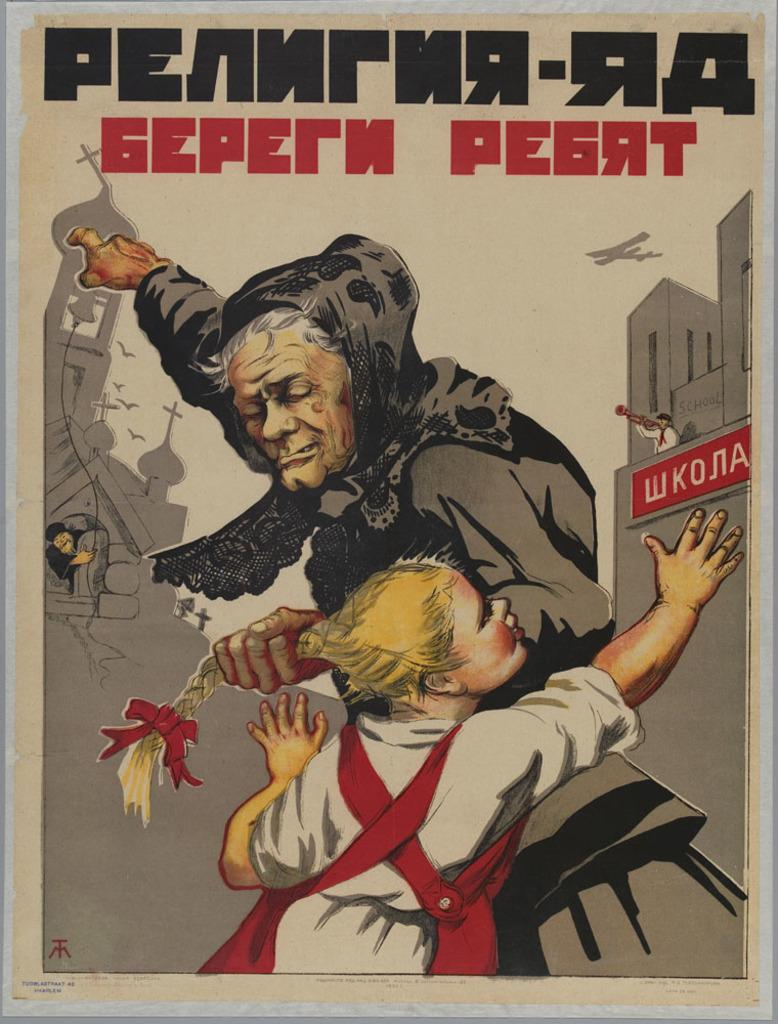What type of artwork is depicted in the image? The image is a painting. Who or what can be seen in the painting? There is a woman and a girl in the painting. What is visible in the background of the painting? There is an aeroplane and buildings in the background of the painting. Is there any text present in the painting? Yes, there is text at the top of the painting. What shape is the sack that the woman is holding in the painting? There is no sack present in the painting; the woman is not holding any object. 